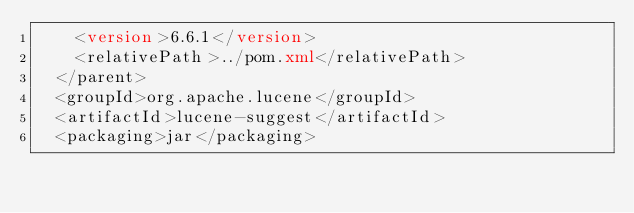<code> <loc_0><loc_0><loc_500><loc_500><_XML_>    <version>6.6.1</version>
    <relativePath>../pom.xml</relativePath>
  </parent>
  <groupId>org.apache.lucene</groupId>
  <artifactId>lucene-suggest</artifactId>
  <packaging>jar</packaging></code> 